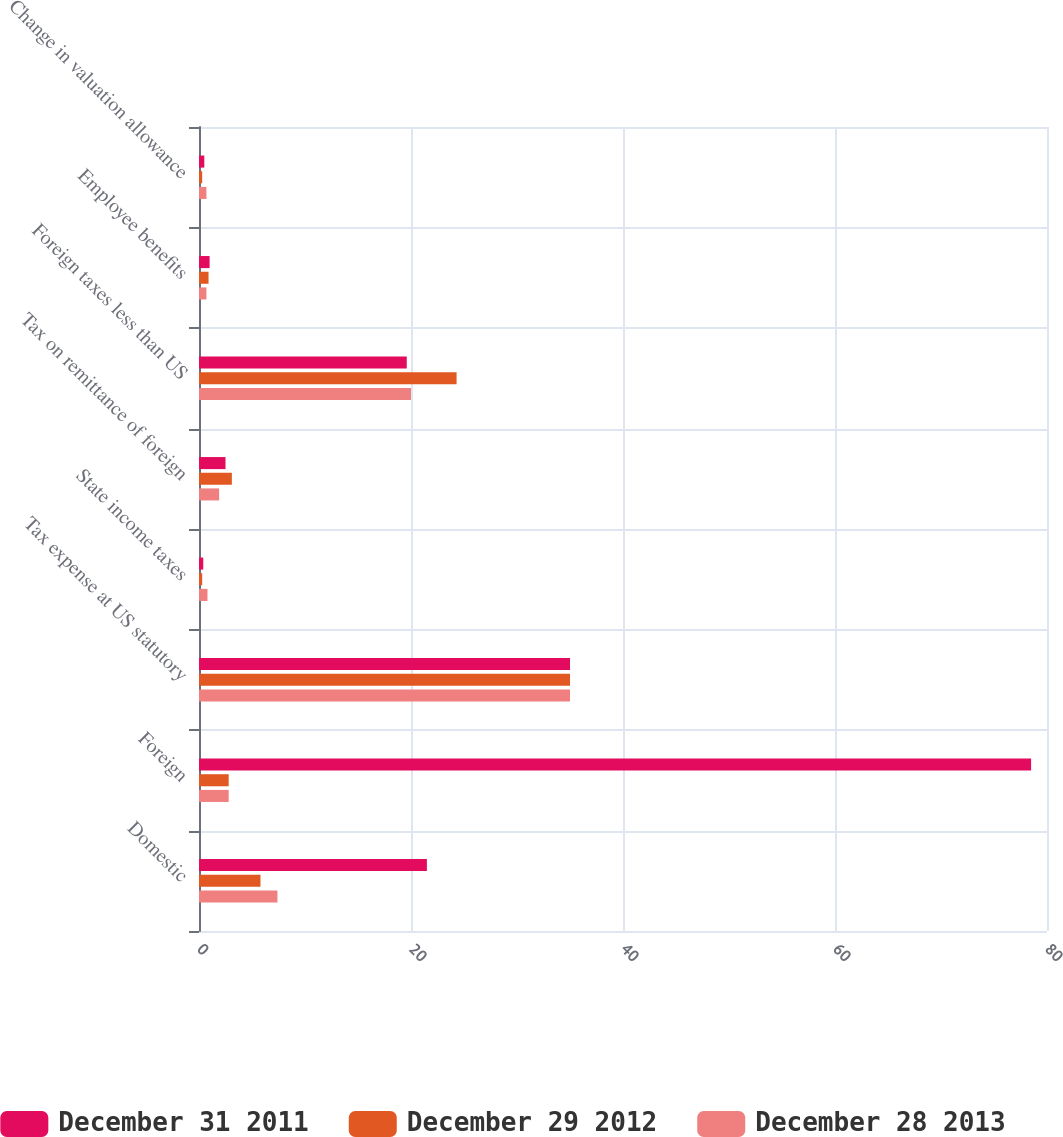<chart> <loc_0><loc_0><loc_500><loc_500><stacked_bar_chart><ecel><fcel>Domestic<fcel>Foreign<fcel>Tax expense at US statutory<fcel>State income taxes<fcel>Tax on remittance of foreign<fcel>Foreign taxes less than US<fcel>Employee benefits<fcel>Change in valuation allowance<nl><fcel>December 31 2011<fcel>21.5<fcel>78.5<fcel>35<fcel>0.4<fcel>2.5<fcel>19.6<fcel>1<fcel>0.5<nl><fcel>December 29 2012<fcel>5.8<fcel>2.8<fcel>35<fcel>0.3<fcel>3.1<fcel>24.3<fcel>0.9<fcel>0.3<nl><fcel>December 28 2013<fcel>7.4<fcel>2.8<fcel>35<fcel>0.8<fcel>1.9<fcel>20<fcel>0.7<fcel>0.7<nl></chart> 